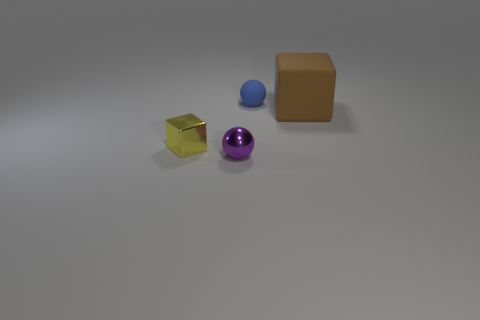What kinds of materials do these objects look like they are made of? The objects present in the image appear to have different textures suggesting they might be made of various materials. The gold-colored cube looks like it could be made of a reflective metal due to its shiny surface. The purple sphere has a less reflective, slightly dulled surface which might indicate a plastic or metallic material with a matte finish. The blue sphere seems to have a soft, velvety texture, possibly indicating a rubber material. Lastly, the brown cube-like object has a non-reflective surface, reminiscent of a rubber or matte plastic. 